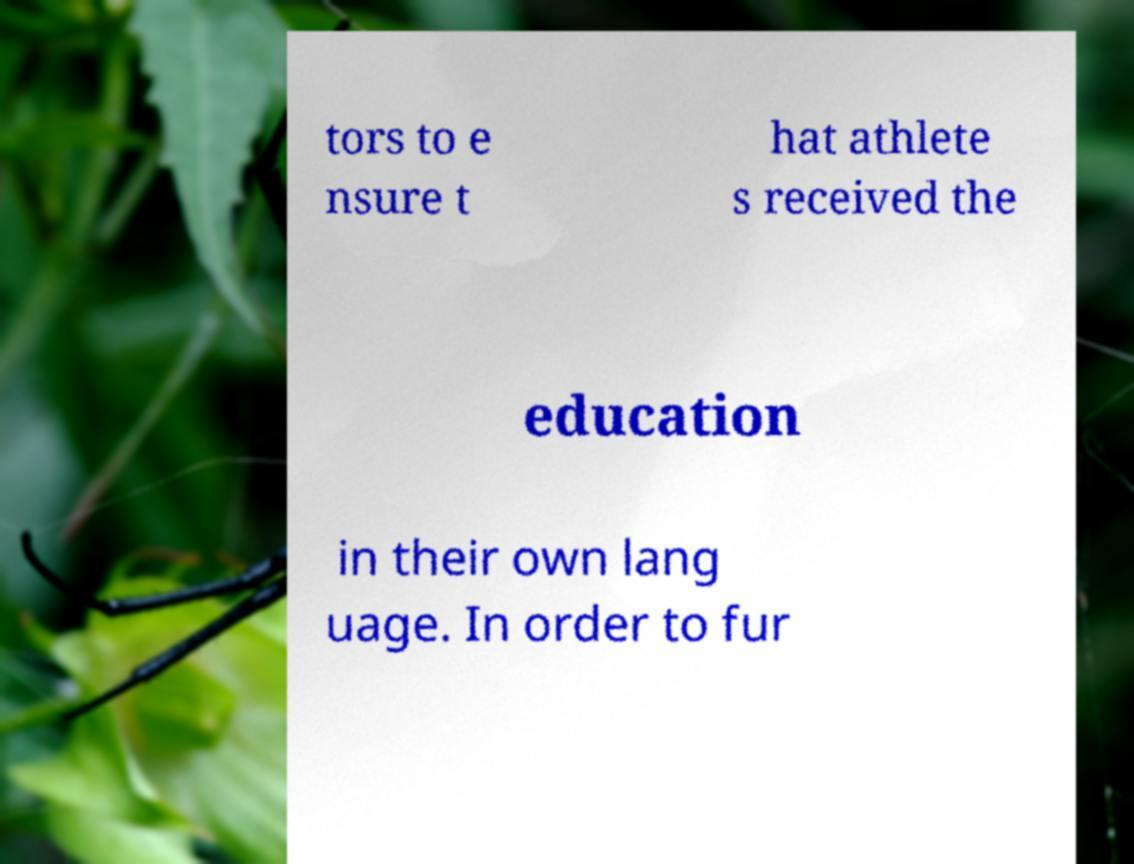Could you extract and type out the text from this image? tors to e nsure t hat athlete s received the education in their own lang uage. In order to fur 